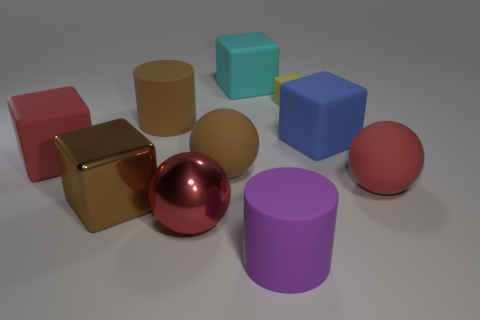Subtract all brown blocks. How many blocks are left? 4 Subtract all brown shiny cubes. How many cubes are left? 4 Subtract all purple cubes. Subtract all brown spheres. How many cubes are left? 5 Subtract all balls. How many objects are left? 7 Add 2 large brown shiny objects. How many large brown shiny objects exist? 3 Subtract 0 green cylinders. How many objects are left? 10 Subtract all small red matte cylinders. Subtract all big brown balls. How many objects are left? 9 Add 9 red cubes. How many red cubes are left? 10 